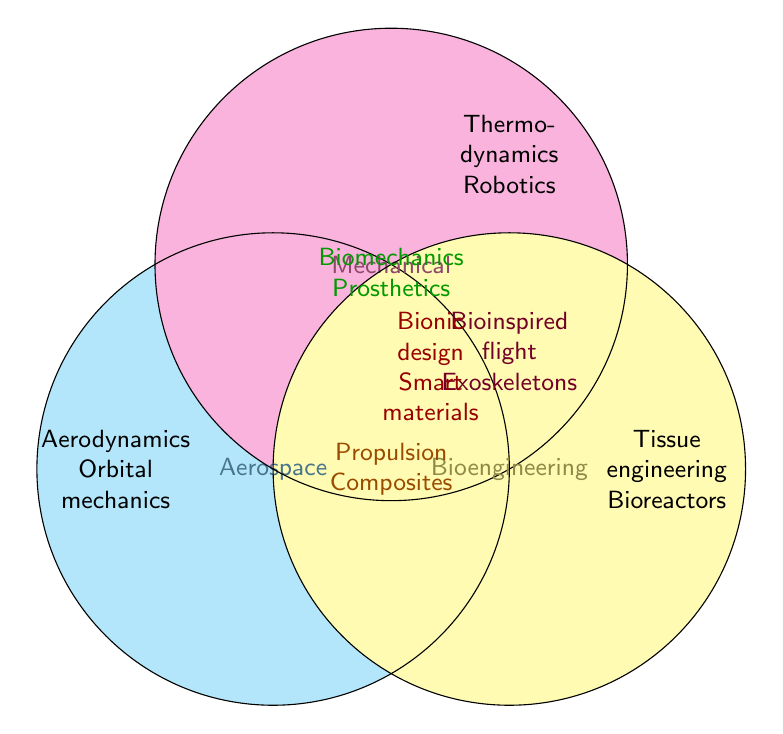Which engineering discipline is associated with "Aerodynamics"? The figure shows "Aerodynamics" in the section exclusively for Aerospace.
Answer: Aerospace Which two disciplines overlap in "Propulsion"? "Propulsion" appears in the overlapping area between Aerospace and Mechanical Engineering in the Venn diagram.
Answer: Aerospace and Mechanical Which discipline is linked to "Tissue engineering"? "Tissue engineering" is found exclusively within the Bioengineering circle.
Answer: Bioengineering Which subjects are shared by all three disciplines? The center section where all three circles overlap contains "Bionic design" and "Smart materials."
Answer: Bionic design and Smart materials Where is "Robotics" placed in the Venn Diagram? "Robotics" is located exclusively within the Mechanical Engineering circle.
Answer: Mechanical Which two disciplines share "Exoskeletons"? "Exoskeletons" appears in the overlapping area between Aerospace and Bioengineering.
Answer: Aerospace and Bioengineering What is the common area for Aerospace and Bioengineering? The figure shows "Bioinspired flight" and "Exoskeletons" in the area overlapping Aerospace and Bioengineering.
Answer: Bioinspired flight and Exoskeletons How many subjects are exclusively related to Mechanical Engineering? The Mechanical Engineering section contains "Thermodynamics" and "Robotics" based on the figure.
Answer: 2 Which engineering discipline is "Prosthetics" associated with besides Bioengineering? "Prosthetics" is in the overlapping area of Bioengineering and Mechanical Engineering.
Answer: Mechanical What is the central visual element in the Venn Diagram? The Venn Diagram's center represents subjects common to Aerospace, Mechanical, and Bioengineering— "Bionic design" and "Smart materials."
Answer: Bionic design and Smart materials 